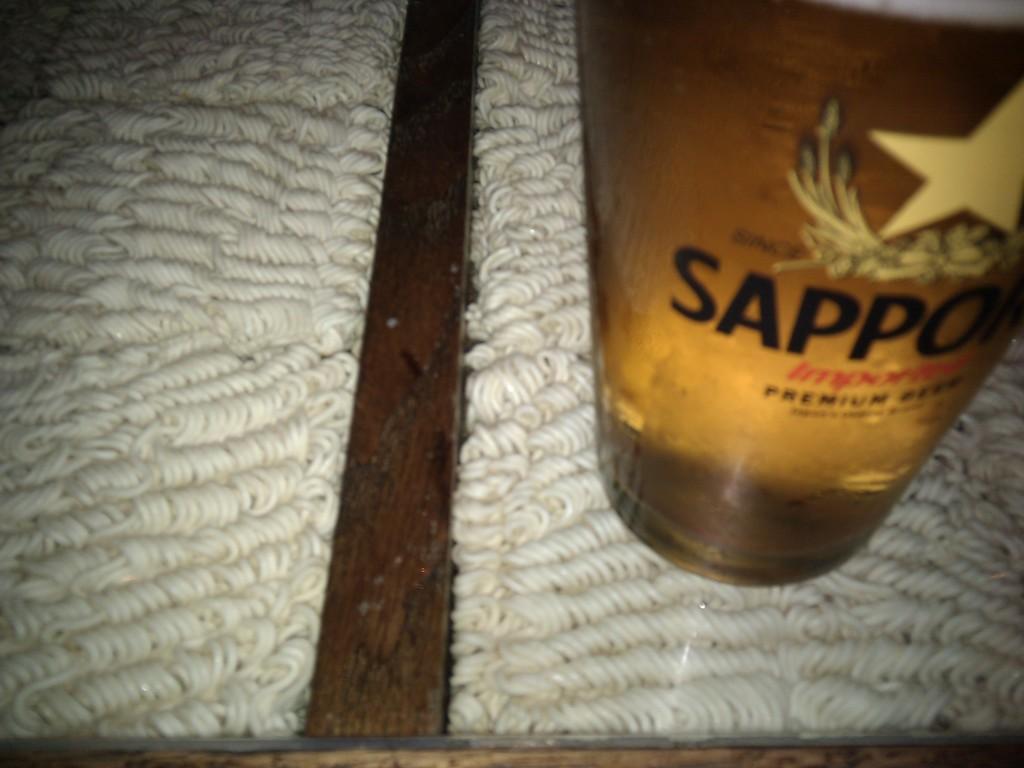What type of premium beverage is this?
Make the answer very short. Beer. 